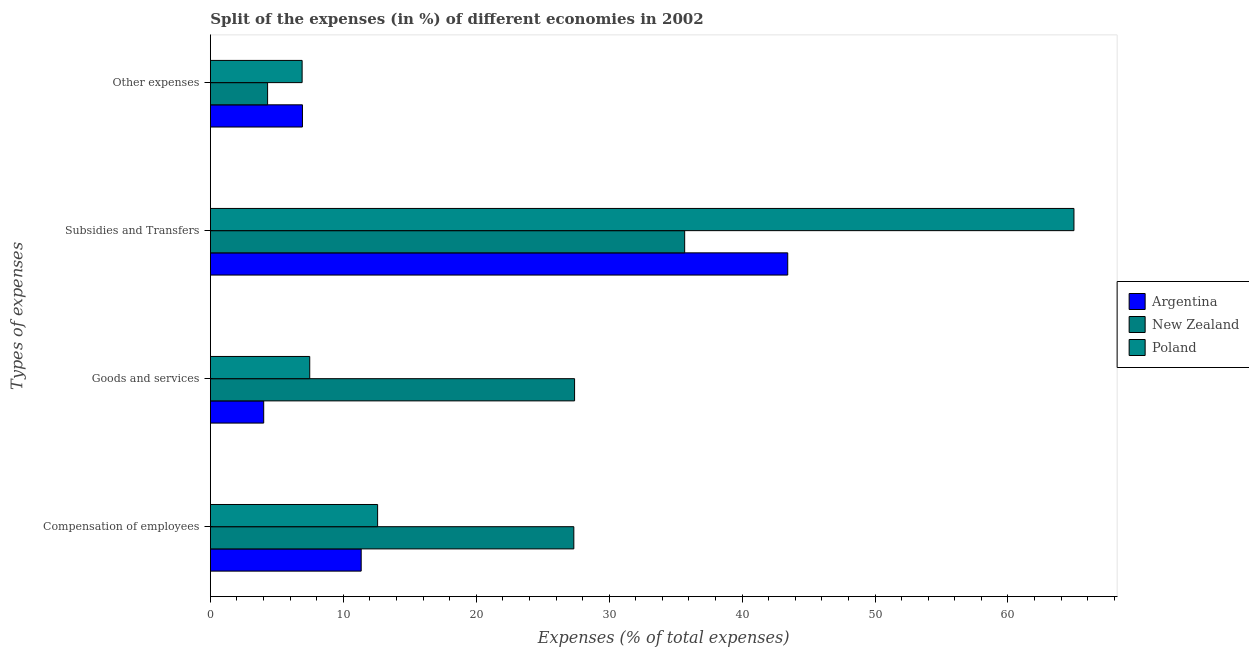How many different coloured bars are there?
Provide a short and direct response. 3. Are the number of bars per tick equal to the number of legend labels?
Ensure brevity in your answer.  Yes. How many bars are there on the 2nd tick from the bottom?
Ensure brevity in your answer.  3. What is the label of the 2nd group of bars from the top?
Ensure brevity in your answer.  Subsidies and Transfers. What is the percentage of amount spent on goods and services in Argentina?
Make the answer very short. 4.01. Across all countries, what is the maximum percentage of amount spent on other expenses?
Your answer should be very brief. 6.93. Across all countries, what is the minimum percentage of amount spent on compensation of employees?
Your answer should be compact. 11.34. In which country was the percentage of amount spent on goods and services minimum?
Give a very brief answer. Argentina. What is the total percentage of amount spent on compensation of employees in the graph?
Your response must be concise. 51.27. What is the difference between the percentage of amount spent on compensation of employees in Argentina and that in New Zealand?
Your answer should be very brief. -16. What is the difference between the percentage of amount spent on compensation of employees in Argentina and the percentage of amount spent on subsidies in Poland?
Keep it short and to the point. -53.62. What is the average percentage of amount spent on subsidies per country?
Offer a very short reply. 48.03. What is the difference between the percentage of amount spent on goods and services and percentage of amount spent on other expenses in New Zealand?
Offer a very short reply. 23.09. What is the ratio of the percentage of amount spent on compensation of employees in New Zealand to that in Argentina?
Make the answer very short. 2.41. Is the difference between the percentage of amount spent on goods and services in Argentina and New Zealand greater than the difference between the percentage of amount spent on compensation of employees in Argentina and New Zealand?
Your answer should be very brief. No. What is the difference between the highest and the second highest percentage of amount spent on other expenses?
Give a very brief answer. 0.02. What is the difference between the highest and the lowest percentage of amount spent on other expenses?
Offer a terse response. 2.62. In how many countries, is the percentage of amount spent on subsidies greater than the average percentage of amount spent on subsidies taken over all countries?
Keep it short and to the point. 1. Is it the case that in every country, the sum of the percentage of amount spent on other expenses and percentage of amount spent on compensation of employees is greater than the sum of percentage of amount spent on goods and services and percentage of amount spent on subsidies?
Your answer should be very brief. No. What does the 3rd bar from the top in Goods and services represents?
Offer a terse response. Argentina. Are all the bars in the graph horizontal?
Offer a terse response. Yes. How many countries are there in the graph?
Give a very brief answer. 3. What is the difference between two consecutive major ticks on the X-axis?
Your response must be concise. 10. Are the values on the major ticks of X-axis written in scientific E-notation?
Your answer should be very brief. No. Does the graph contain grids?
Make the answer very short. No. What is the title of the graph?
Make the answer very short. Split of the expenses (in %) of different economies in 2002. Does "Panama" appear as one of the legend labels in the graph?
Offer a very short reply. No. What is the label or title of the X-axis?
Ensure brevity in your answer.  Expenses (% of total expenses). What is the label or title of the Y-axis?
Provide a succinct answer. Types of expenses. What is the Expenses (% of total expenses) in Argentina in Compensation of employees?
Keep it short and to the point. 11.34. What is the Expenses (% of total expenses) of New Zealand in Compensation of employees?
Offer a terse response. 27.34. What is the Expenses (% of total expenses) in Poland in Compensation of employees?
Your answer should be very brief. 12.58. What is the Expenses (% of total expenses) of Argentina in Goods and services?
Make the answer very short. 4.01. What is the Expenses (% of total expenses) in New Zealand in Goods and services?
Provide a succinct answer. 27.4. What is the Expenses (% of total expenses) of Poland in Goods and services?
Keep it short and to the point. 7.47. What is the Expenses (% of total expenses) in Argentina in Subsidies and Transfers?
Your response must be concise. 43.43. What is the Expenses (% of total expenses) of New Zealand in Subsidies and Transfers?
Provide a succinct answer. 35.68. What is the Expenses (% of total expenses) in Poland in Subsidies and Transfers?
Make the answer very short. 64.96. What is the Expenses (% of total expenses) of Argentina in Other expenses?
Offer a terse response. 6.93. What is the Expenses (% of total expenses) in New Zealand in Other expenses?
Offer a terse response. 4.3. What is the Expenses (% of total expenses) of Poland in Other expenses?
Offer a terse response. 6.9. Across all Types of expenses, what is the maximum Expenses (% of total expenses) in Argentina?
Offer a terse response. 43.43. Across all Types of expenses, what is the maximum Expenses (% of total expenses) in New Zealand?
Give a very brief answer. 35.68. Across all Types of expenses, what is the maximum Expenses (% of total expenses) in Poland?
Make the answer very short. 64.96. Across all Types of expenses, what is the minimum Expenses (% of total expenses) in Argentina?
Provide a short and direct response. 4.01. Across all Types of expenses, what is the minimum Expenses (% of total expenses) in New Zealand?
Your response must be concise. 4.3. Across all Types of expenses, what is the minimum Expenses (% of total expenses) in Poland?
Provide a succinct answer. 6.9. What is the total Expenses (% of total expenses) in Argentina in the graph?
Provide a short and direct response. 65.71. What is the total Expenses (% of total expenses) of New Zealand in the graph?
Provide a short and direct response. 94.72. What is the total Expenses (% of total expenses) of Poland in the graph?
Your answer should be very brief. 91.92. What is the difference between the Expenses (% of total expenses) in Argentina in Compensation of employees and that in Goods and services?
Your answer should be compact. 7.33. What is the difference between the Expenses (% of total expenses) of New Zealand in Compensation of employees and that in Goods and services?
Keep it short and to the point. -0.06. What is the difference between the Expenses (% of total expenses) of Poland in Compensation of employees and that in Goods and services?
Offer a very short reply. 5.11. What is the difference between the Expenses (% of total expenses) in Argentina in Compensation of employees and that in Subsidies and Transfers?
Keep it short and to the point. -32.09. What is the difference between the Expenses (% of total expenses) in New Zealand in Compensation of employees and that in Subsidies and Transfers?
Your response must be concise. -8.34. What is the difference between the Expenses (% of total expenses) of Poland in Compensation of employees and that in Subsidies and Transfers?
Offer a terse response. -52.38. What is the difference between the Expenses (% of total expenses) of Argentina in Compensation of employees and that in Other expenses?
Your answer should be compact. 4.42. What is the difference between the Expenses (% of total expenses) of New Zealand in Compensation of employees and that in Other expenses?
Make the answer very short. 23.04. What is the difference between the Expenses (% of total expenses) in Poland in Compensation of employees and that in Other expenses?
Provide a succinct answer. 5.68. What is the difference between the Expenses (% of total expenses) of Argentina in Goods and services and that in Subsidies and Transfers?
Provide a short and direct response. -39.42. What is the difference between the Expenses (% of total expenses) of New Zealand in Goods and services and that in Subsidies and Transfers?
Keep it short and to the point. -8.28. What is the difference between the Expenses (% of total expenses) of Poland in Goods and services and that in Subsidies and Transfers?
Your response must be concise. -57.49. What is the difference between the Expenses (% of total expenses) of Argentina in Goods and services and that in Other expenses?
Provide a succinct answer. -2.91. What is the difference between the Expenses (% of total expenses) in New Zealand in Goods and services and that in Other expenses?
Offer a terse response. 23.09. What is the difference between the Expenses (% of total expenses) in Poland in Goods and services and that in Other expenses?
Offer a terse response. 0.57. What is the difference between the Expenses (% of total expenses) of Argentina in Subsidies and Transfers and that in Other expenses?
Offer a very short reply. 36.51. What is the difference between the Expenses (% of total expenses) of New Zealand in Subsidies and Transfers and that in Other expenses?
Keep it short and to the point. 31.38. What is the difference between the Expenses (% of total expenses) of Poland in Subsidies and Transfers and that in Other expenses?
Provide a short and direct response. 58.06. What is the difference between the Expenses (% of total expenses) of Argentina in Compensation of employees and the Expenses (% of total expenses) of New Zealand in Goods and services?
Your answer should be compact. -16.05. What is the difference between the Expenses (% of total expenses) in Argentina in Compensation of employees and the Expenses (% of total expenses) in Poland in Goods and services?
Offer a terse response. 3.87. What is the difference between the Expenses (% of total expenses) in New Zealand in Compensation of employees and the Expenses (% of total expenses) in Poland in Goods and services?
Your answer should be compact. 19.87. What is the difference between the Expenses (% of total expenses) in Argentina in Compensation of employees and the Expenses (% of total expenses) in New Zealand in Subsidies and Transfers?
Offer a very short reply. -24.34. What is the difference between the Expenses (% of total expenses) of Argentina in Compensation of employees and the Expenses (% of total expenses) of Poland in Subsidies and Transfers?
Give a very brief answer. -53.62. What is the difference between the Expenses (% of total expenses) of New Zealand in Compensation of employees and the Expenses (% of total expenses) of Poland in Subsidies and Transfers?
Your answer should be compact. -37.62. What is the difference between the Expenses (% of total expenses) in Argentina in Compensation of employees and the Expenses (% of total expenses) in New Zealand in Other expenses?
Your answer should be very brief. 7.04. What is the difference between the Expenses (% of total expenses) in Argentina in Compensation of employees and the Expenses (% of total expenses) in Poland in Other expenses?
Give a very brief answer. 4.44. What is the difference between the Expenses (% of total expenses) of New Zealand in Compensation of employees and the Expenses (% of total expenses) of Poland in Other expenses?
Give a very brief answer. 20.44. What is the difference between the Expenses (% of total expenses) of Argentina in Goods and services and the Expenses (% of total expenses) of New Zealand in Subsidies and Transfers?
Provide a short and direct response. -31.67. What is the difference between the Expenses (% of total expenses) in Argentina in Goods and services and the Expenses (% of total expenses) in Poland in Subsidies and Transfers?
Provide a short and direct response. -60.95. What is the difference between the Expenses (% of total expenses) of New Zealand in Goods and services and the Expenses (% of total expenses) of Poland in Subsidies and Transfers?
Ensure brevity in your answer.  -37.57. What is the difference between the Expenses (% of total expenses) in Argentina in Goods and services and the Expenses (% of total expenses) in New Zealand in Other expenses?
Ensure brevity in your answer.  -0.29. What is the difference between the Expenses (% of total expenses) of Argentina in Goods and services and the Expenses (% of total expenses) of Poland in Other expenses?
Provide a succinct answer. -2.89. What is the difference between the Expenses (% of total expenses) in New Zealand in Goods and services and the Expenses (% of total expenses) in Poland in Other expenses?
Make the answer very short. 20.5. What is the difference between the Expenses (% of total expenses) in Argentina in Subsidies and Transfers and the Expenses (% of total expenses) in New Zealand in Other expenses?
Offer a terse response. 39.13. What is the difference between the Expenses (% of total expenses) of Argentina in Subsidies and Transfers and the Expenses (% of total expenses) of Poland in Other expenses?
Your response must be concise. 36.53. What is the difference between the Expenses (% of total expenses) of New Zealand in Subsidies and Transfers and the Expenses (% of total expenses) of Poland in Other expenses?
Give a very brief answer. 28.78. What is the average Expenses (% of total expenses) in Argentina per Types of expenses?
Your answer should be compact. 16.43. What is the average Expenses (% of total expenses) in New Zealand per Types of expenses?
Provide a succinct answer. 23.68. What is the average Expenses (% of total expenses) of Poland per Types of expenses?
Give a very brief answer. 22.98. What is the difference between the Expenses (% of total expenses) of Argentina and Expenses (% of total expenses) of New Zealand in Compensation of employees?
Give a very brief answer. -16. What is the difference between the Expenses (% of total expenses) in Argentina and Expenses (% of total expenses) in Poland in Compensation of employees?
Offer a terse response. -1.24. What is the difference between the Expenses (% of total expenses) in New Zealand and Expenses (% of total expenses) in Poland in Compensation of employees?
Give a very brief answer. 14.76. What is the difference between the Expenses (% of total expenses) of Argentina and Expenses (% of total expenses) of New Zealand in Goods and services?
Make the answer very short. -23.39. What is the difference between the Expenses (% of total expenses) of Argentina and Expenses (% of total expenses) of Poland in Goods and services?
Give a very brief answer. -3.46. What is the difference between the Expenses (% of total expenses) of New Zealand and Expenses (% of total expenses) of Poland in Goods and services?
Your answer should be very brief. 19.92. What is the difference between the Expenses (% of total expenses) of Argentina and Expenses (% of total expenses) of New Zealand in Subsidies and Transfers?
Give a very brief answer. 7.75. What is the difference between the Expenses (% of total expenses) in Argentina and Expenses (% of total expenses) in Poland in Subsidies and Transfers?
Offer a terse response. -21.53. What is the difference between the Expenses (% of total expenses) in New Zealand and Expenses (% of total expenses) in Poland in Subsidies and Transfers?
Your answer should be compact. -29.28. What is the difference between the Expenses (% of total expenses) in Argentina and Expenses (% of total expenses) in New Zealand in Other expenses?
Your answer should be very brief. 2.62. What is the difference between the Expenses (% of total expenses) of Argentina and Expenses (% of total expenses) of Poland in Other expenses?
Make the answer very short. 0.02. What is the difference between the Expenses (% of total expenses) of New Zealand and Expenses (% of total expenses) of Poland in Other expenses?
Offer a very short reply. -2.6. What is the ratio of the Expenses (% of total expenses) in Argentina in Compensation of employees to that in Goods and services?
Your answer should be compact. 2.83. What is the ratio of the Expenses (% of total expenses) of Poland in Compensation of employees to that in Goods and services?
Provide a short and direct response. 1.68. What is the ratio of the Expenses (% of total expenses) in Argentina in Compensation of employees to that in Subsidies and Transfers?
Ensure brevity in your answer.  0.26. What is the ratio of the Expenses (% of total expenses) in New Zealand in Compensation of employees to that in Subsidies and Transfers?
Provide a short and direct response. 0.77. What is the ratio of the Expenses (% of total expenses) in Poland in Compensation of employees to that in Subsidies and Transfers?
Provide a succinct answer. 0.19. What is the ratio of the Expenses (% of total expenses) of Argentina in Compensation of employees to that in Other expenses?
Ensure brevity in your answer.  1.64. What is the ratio of the Expenses (% of total expenses) in New Zealand in Compensation of employees to that in Other expenses?
Give a very brief answer. 6.35. What is the ratio of the Expenses (% of total expenses) of Poland in Compensation of employees to that in Other expenses?
Offer a very short reply. 1.82. What is the ratio of the Expenses (% of total expenses) of Argentina in Goods and services to that in Subsidies and Transfers?
Offer a terse response. 0.09. What is the ratio of the Expenses (% of total expenses) of New Zealand in Goods and services to that in Subsidies and Transfers?
Make the answer very short. 0.77. What is the ratio of the Expenses (% of total expenses) of Poland in Goods and services to that in Subsidies and Transfers?
Offer a very short reply. 0.12. What is the ratio of the Expenses (% of total expenses) of Argentina in Goods and services to that in Other expenses?
Provide a succinct answer. 0.58. What is the ratio of the Expenses (% of total expenses) of New Zealand in Goods and services to that in Other expenses?
Your answer should be very brief. 6.37. What is the ratio of the Expenses (% of total expenses) of Poland in Goods and services to that in Other expenses?
Give a very brief answer. 1.08. What is the ratio of the Expenses (% of total expenses) of Argentina in Subsidies and Transfers to that in Other expenses?
Give a very brief answer. 6.27. What is the ratio of the Expenses (% of total expenses) in New Zealand in Subsidies and Transfers to that in Other expenses?
Provide a short and direct response. 8.29. What is the ratio of the Expenses (% of total expenses) in Poland in Subsidies and Transfers to that in Other expenses?
Offer a terse response. 9.41. What is the difference between the highest and the second highest Expenses (% of total expenses) in Argentina?
Ensure brevity in your answer.  32.09. What is the difference between the highest and the second highest Expenses (% of total expenses) of New Zealand?
Your answer should be compact. 8.28. What is the difference between the highest and the second highest Expenses (% of total expenses) in Poland?
Your answer should be very brief. 52.38. What is the difference between the highest and the lowest Expenses (% of total expenses) in Argentina?
Your answer should be compact. 39.42. What is the difference between the highest and the lowest Expenses (% of total expenses) in New Zealand?
Keep it short and to the point. 31.38. What is the difference between the highest and the lowest Expenses (% of total expenses) of Poland?
Your answer should be very brief. 58.06. 